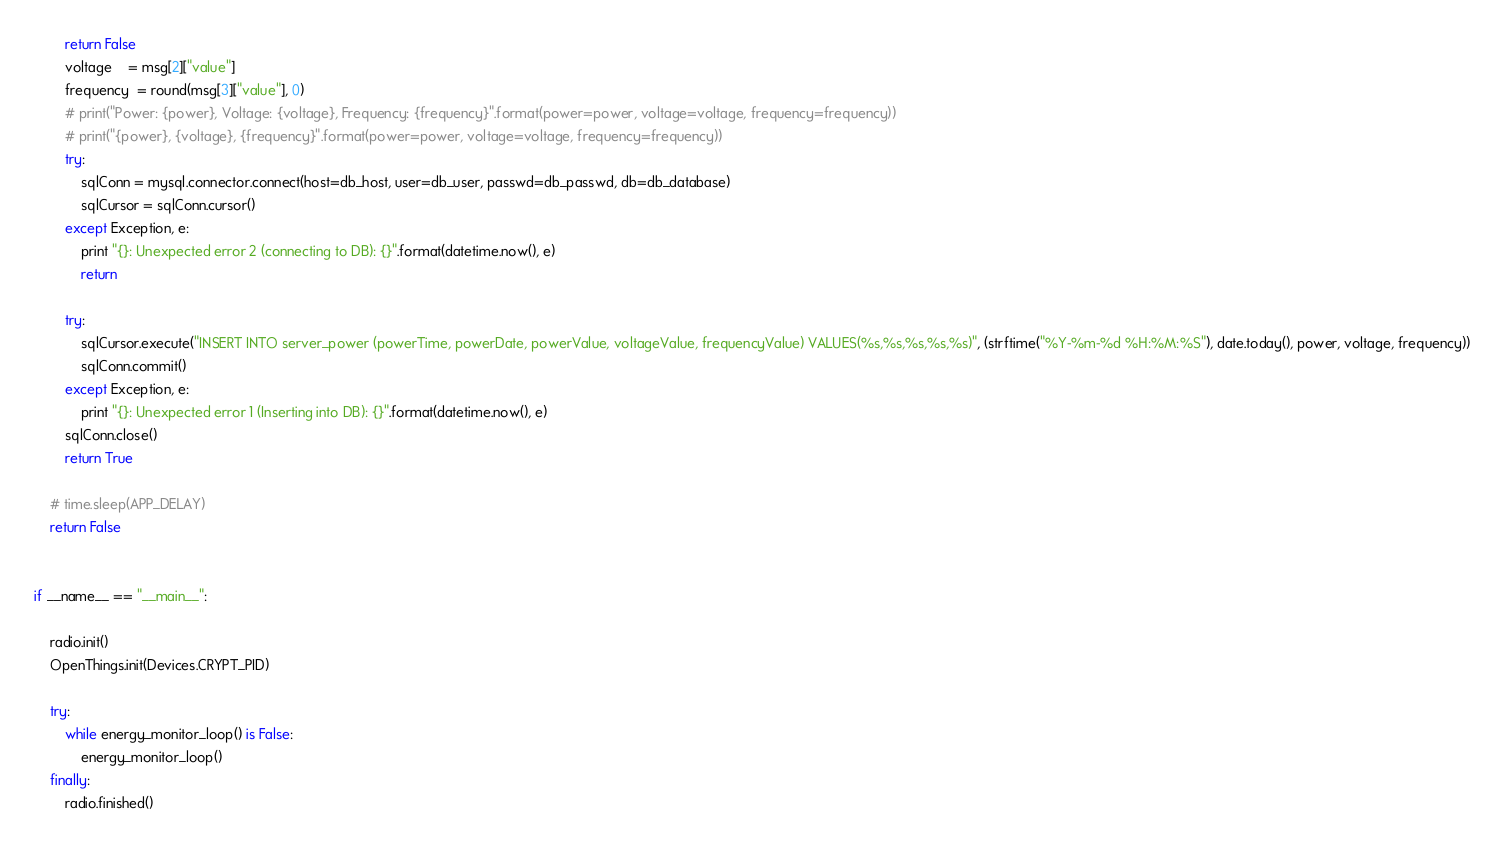Convert code to text. <code><loc_0><loc_0><loc_500><loc_500><_Python_>	    return False
        voltage    = msg[2]["value"]
        frequency  = round(msg[3]["value"], 0)
        # print("Power: {power}, Voltage: {voltage}, Frequency: {frequency}".format(power=power, voltage=voltage, frequency=frequency))
        # print("{power}, {voltage}, {frequency}".format(power=power, voltage=voltage, frequency=frequency))
        try:
            sqlConn = mysql.connector.connect(host=db_host, user=db_user, passwd=db_passwd, db=db_database)
            sqlCursor = sqlConn.cursor()
        except Exception, e:
            print "{}: Unexpected error 2 (connecting to DB): {}".format(datetime.now(), e)
            return

        try:
            sqlCursor.execute("INSERT INTO server_power (powerTime, powerDate, powerValue, voltageValue, frequencyValue) VALUES(%s,%s,%s,%s,%s)", (strftime("%Y-%m-%d %H:%M:%S"), date.today(), power, voltage, frequency))
            sqlConn.commit()
        except Exception, e:
            print "{}: Unexpected error 1 (Inserting into DB): {}".format(datetime.now(), e)
        sqlConn.close()
        return True

    # time.sleep(APP_DELAY)
    return False


if __name__ == "__main__":

    radio.init()
    OpenThings.init(Devices.CRYPT_PID)

    try:
        while energy_monitor_loop() is False:
            energy_monitor_loop()
    finally:
        radio.finished()

</code> 